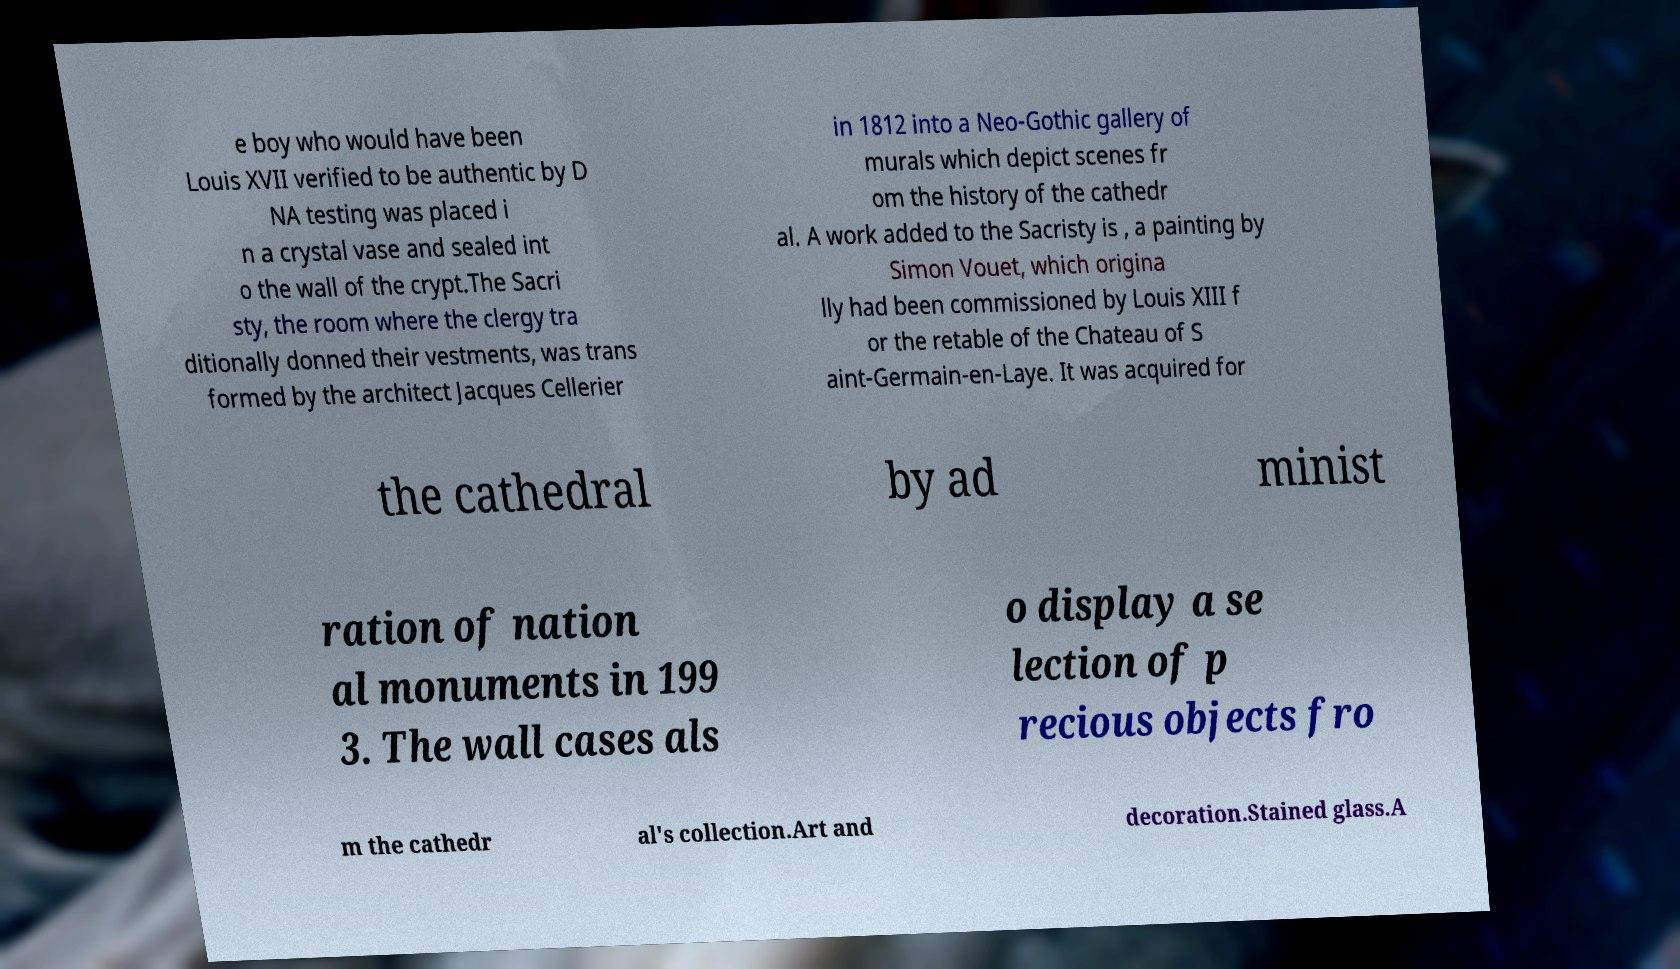Please identify and transcribe the text found in this image. e boy who would have been Louis XVII verified to be authentic by D NA testing was placed i n a crystal vase and sealed int o the wall of the crypt.The Sacri sty, the room where the clergy tra ditionally donned their vestments, was trans formed by the architect Jacques Cellerier in 1812 into a Neo-Gothic gallery of murals which depict scenes fr om the history of the cathedr al. A work added to the Sacristy is , a painting by Simon Vouet, which origina lly had been commissioned by Louis XIII f or the retable of the Chateau of S aint-Germain-en-Laye. It was acquired for the cathedral by ad minist ration of nation al monuments in 199 3. The wall cases als o display a se lection of p recious objects fro m the cathedr al's collection.Art and decoration.Stained glass.A 